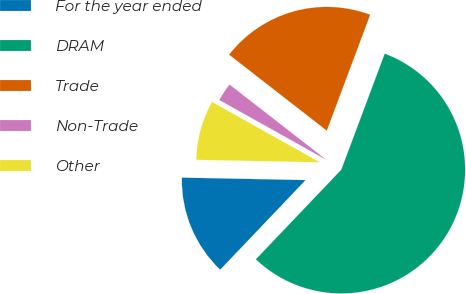<chart> <loc_0><loc_0><loc_500><loc_500><pie_chart><fcel>For the year ended<fcel>DRAM<fcel>Trade<fcel>Non-Trade<fcel>Other<nl><fcel>13.2%<fcel>56.42%<fcel>20.18%<fcel>2.4%<fcel>7.8%<nl></chart> 